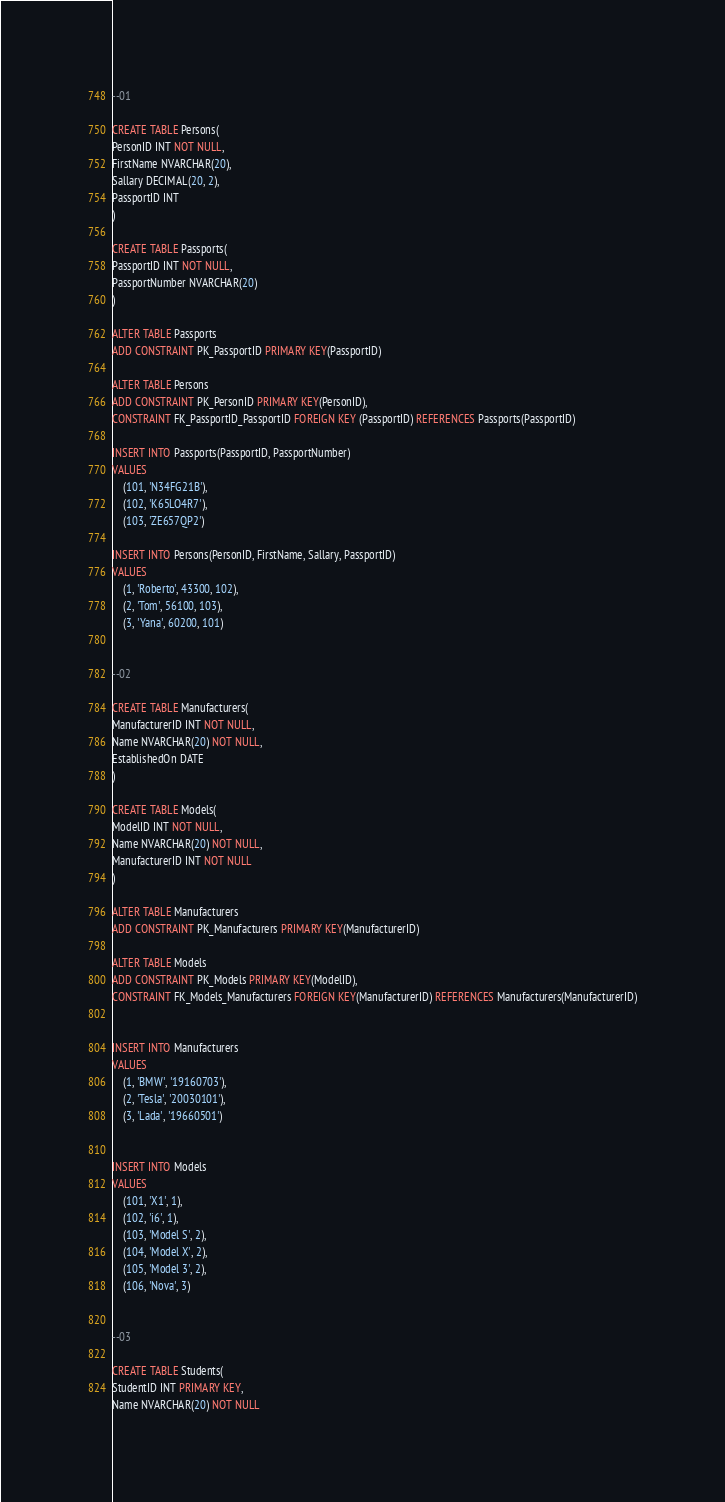Convert code to text. <code><loc_0><loc_0><loc_500><loc_500><_SQL_>--01

CREATE TABLE Persons(
PersonID INT NOT NULL,
FirstName NVARCHAR(20),
Sallary DECIMAL(20, 2),
PassportID INT
)

CREATE TABLE Passports(
PassportID INT NOT NULL,
PassportNumber NVARCHAR(20)
)

ALTER TABLE Passports
ADD CONSTRAINT PK_PassportID PRIMARY KEY(PassportID)

ALTER TABLE Persons
ADD CONSTRAINT PK_PersonID PRIMARY KEY(PersonID),
CONSTRAINT FK_PassportID_PassportID FOREIGN KEY (PassportID) REFERENCES Passports(PassportID)

INSERT INTO Passports(PassportID, PassportNumber)
VALUES
	(101, 'N34FG21B'),
	(102, 'K65LO4R7'),
	(103, 'ZE657QP2')

INSERT INTO Persons(PersonID, FirstName, Sallary, PassportID)
VALUES
	(1, 'Roberto', 43300, 102),
	(2, 'Tom', 56100, 103),
	(3, 'Yana', 60200, 101)


--02

CREATE TABLE Manufacturers(
ManufacturerID INT NOT NULL,
Name NVARCHAR(20) NOT NULL,
EstablishedOn DATE
)

CREATE TABLE Models(
ModelID INT NOT NULL,
Name NVARCHAR(20) NOT NULL,
ManufacturerID INT NOT NULL
)

ALTER TABLE Manufacturers
ADD CONSTRAINT PK_Manufacturers PRIMARY KEY(ManufacturerID)

ALTER TABLE Models
ADD CONSTRAINT PK_Models PRIMARY KEY(ModelID),
CONSTRAINT FK_Models_Manufacturers FOREIGN KEY(ManufacturerID) REFERENCES Manufacturers(ManufacturerID)


INSERT INTO Manufacturers
VALUES
	(1, 'BMW', '19160703'),
	(2, 'Tesla', '20030101'),
	(3, 'Lada', '19660501')

	
INSERT INTO Models
VALUES
	(101, 'X1', 1),
	(102, 'i6', 1),
	(103, 'Model S', 2),
	(104, 'Model X', 2),
	(105, 'Model 3', 2),
	(106, 'Nova', 3)


--03

CREATE TABLE Students(
StudentID INT PRIMARY KEY,
Name NVARCHAR(20) NOT NULL</code> 